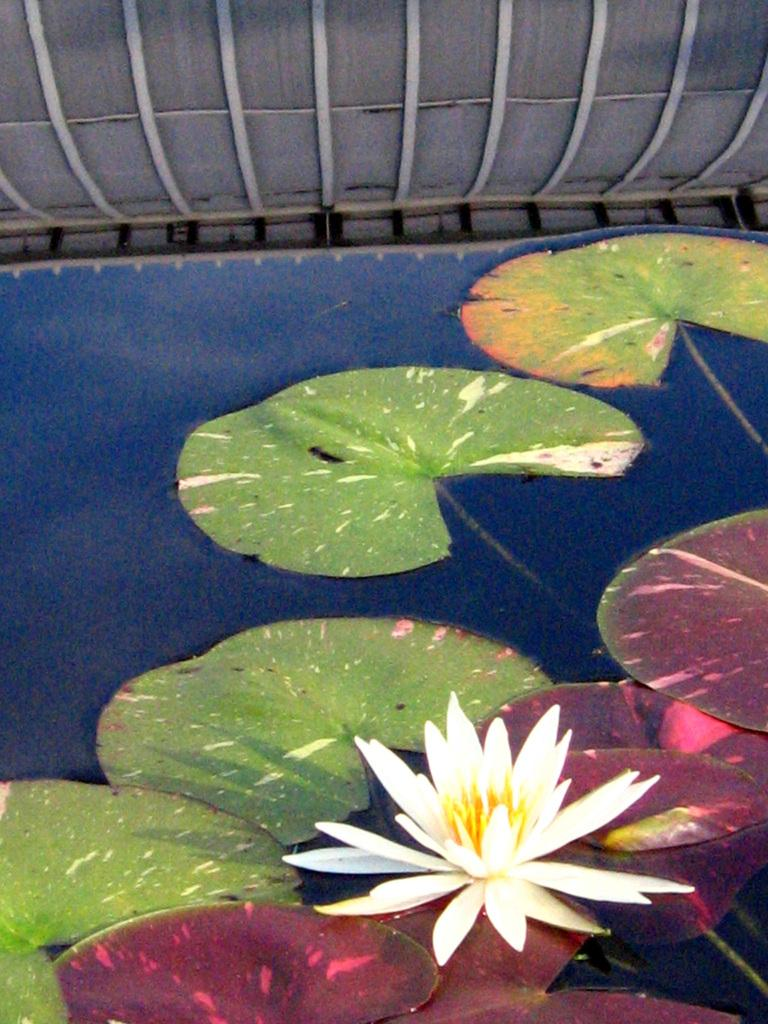What is the main subject of the image? There is a painting in the image. What is depicted in the painting? The painting contains a lotus and leaves. What color is dominant in the painting? The painting has blue color. How many geese are participating in the competition depicted in the painting? There are no geese or competition present in the painting; it features a lotus and leaves in a blue color scheme. 